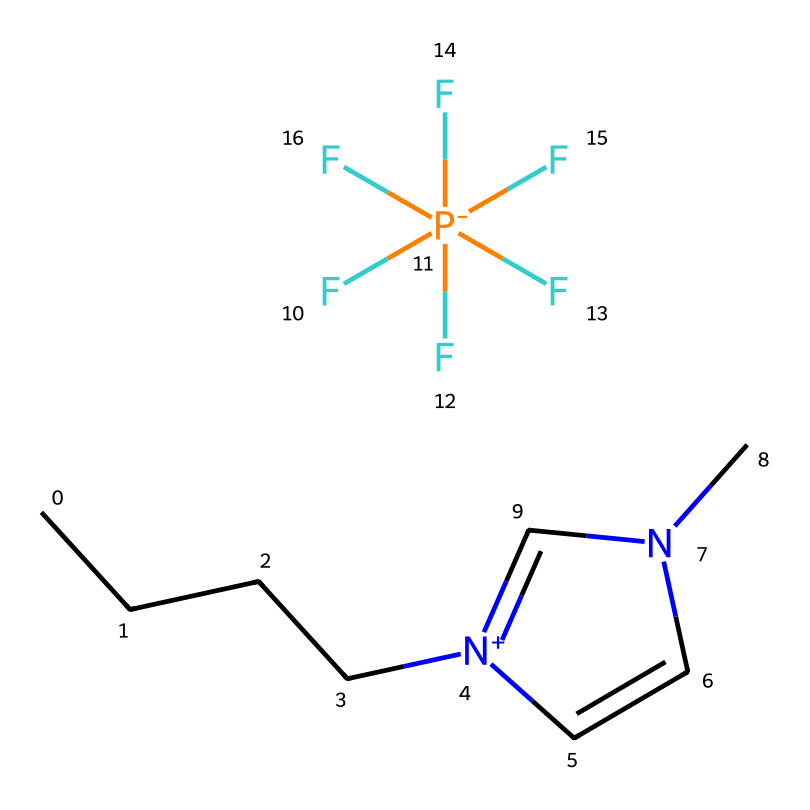What is the total number of carbon atoms in this ionic liquid? By analyzing the SMILES representation, "CCCC" indicates straight-chain carbon atoms, and the "n" in the imidazolium ring additionally contributes two more carbons. Together, this gives a total of 6 carbon atoms (4 from "CCCC" and 2 from the ring).
Answer: 6 What is the charge of the cation in this chemical? The structure contains a nitrogen atom within the imidazolium ring, which indicates that it is a positively charged cation. Thus, the cation has a formal positive charge.
Answer: positive How many fluorine atoms are present in the anion? The notation "[P-](F)(F)(F)(F)(F)F" indicates that the phosphorus atom is bonded to six fluorine atoms. This can be counted directly from the notation.
Answer: 6 What functional group is present in this ionic liquid? The presence of the "n" in the ring structure indicates it features a nitrogen atom, which is a characteristic of imidazolium, a type of functional group.
Answer: imidazolium What is the primary application of 1-butyl-3-methylimidazolium hexafluorophosphate in propulsion systems? 1-butyl-3-methylimidazolium hexafluorophosphate is used as an electrolyte in high-temperature fuel cells, which are crucial for efficient propulsion systems in aerospace applications.
Answer: electrolyte What does the presence of the hexafluorophosphate ion indicate about the ionic liquid's properties? The hexafluorophosphate ion is known for its stability and ability to dissolve in various solvents, indicating that this ionic liquid is likely to possess good conductivity and thermal stability, making it suitable for high-temperature applications.
Answer: stability What type of bonding is primarily present in ionic liquids like this one? Ionic liquids are characterized by ionic bonding, specifically between cations and anions, which is evident from the overall structure showing charges associated with the cation and anion.
Answer: ionic 